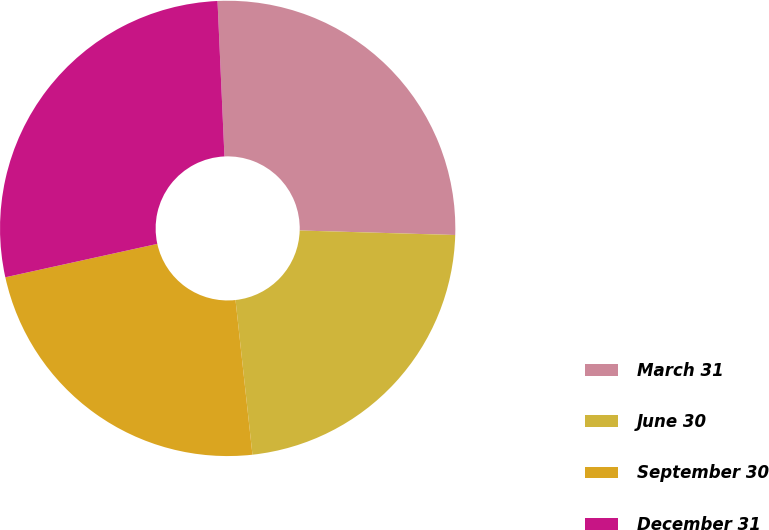Convert chart to OTSL. <chart><loc_0><loc_0><loc_500><loc_500><pie_chart><fcel>March 31<fcel>June 30<fcel>September 30<fcel>December 31<nl><fcel>26.17%<fcel>22.8%<fcel>23.29%<fcel>27.73%<nl></chart> 